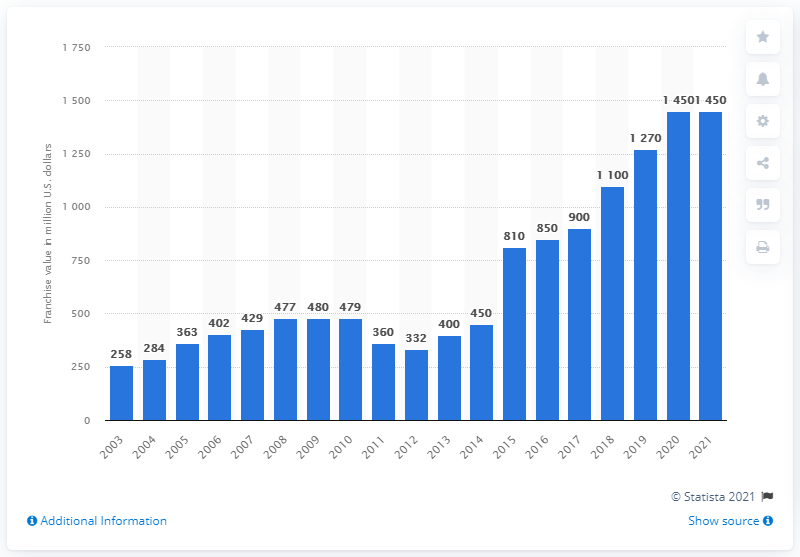Point out several critical features in this image. The estimated value of the Detroit Pistons in 2021 was approximately $1,450. 